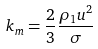Convert formula to latex. <formula><loc_0><loc_0><loc_500><loc_500>k _ { m } = \frac { 2 } { 3 } \frac { \rho _ { 1 } u ^ { 2 } } { \sigma }</formula> 